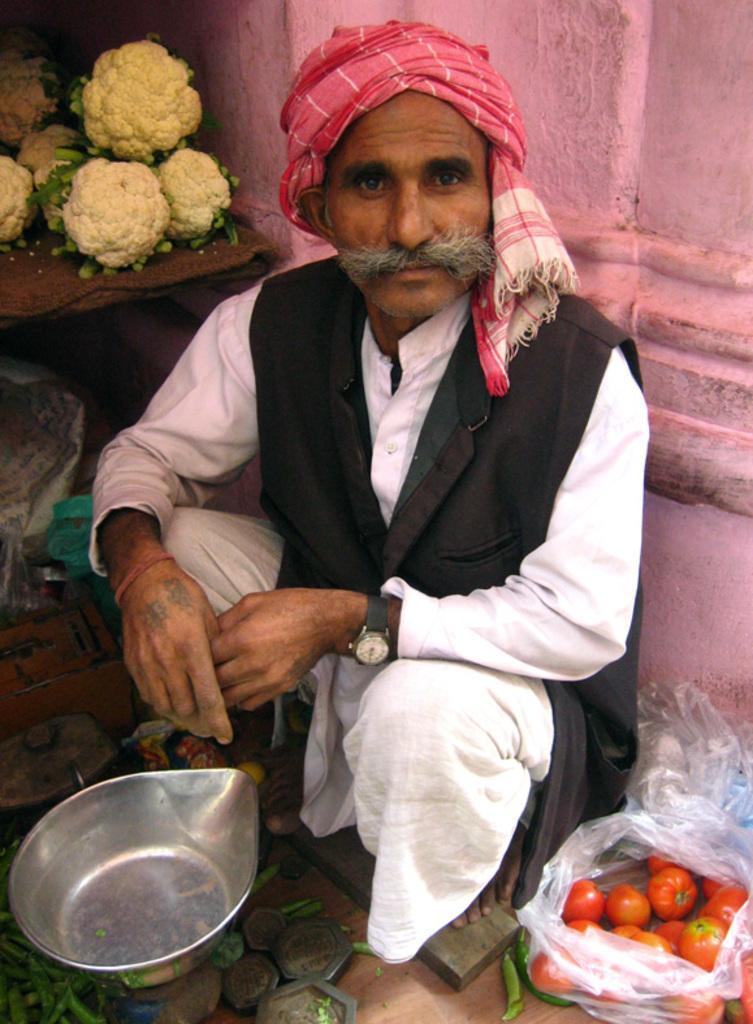Describe this image in one or two sentences. In the foreground of this image, there is a man wearing black coat and also wearing a turban on his head is squatting in front of a weighing machine and the pan. On the right bottom, there are tomatoes in a cover and in the background, there is a pink wall, cauliflowers on a table and under the table there are few objects. 